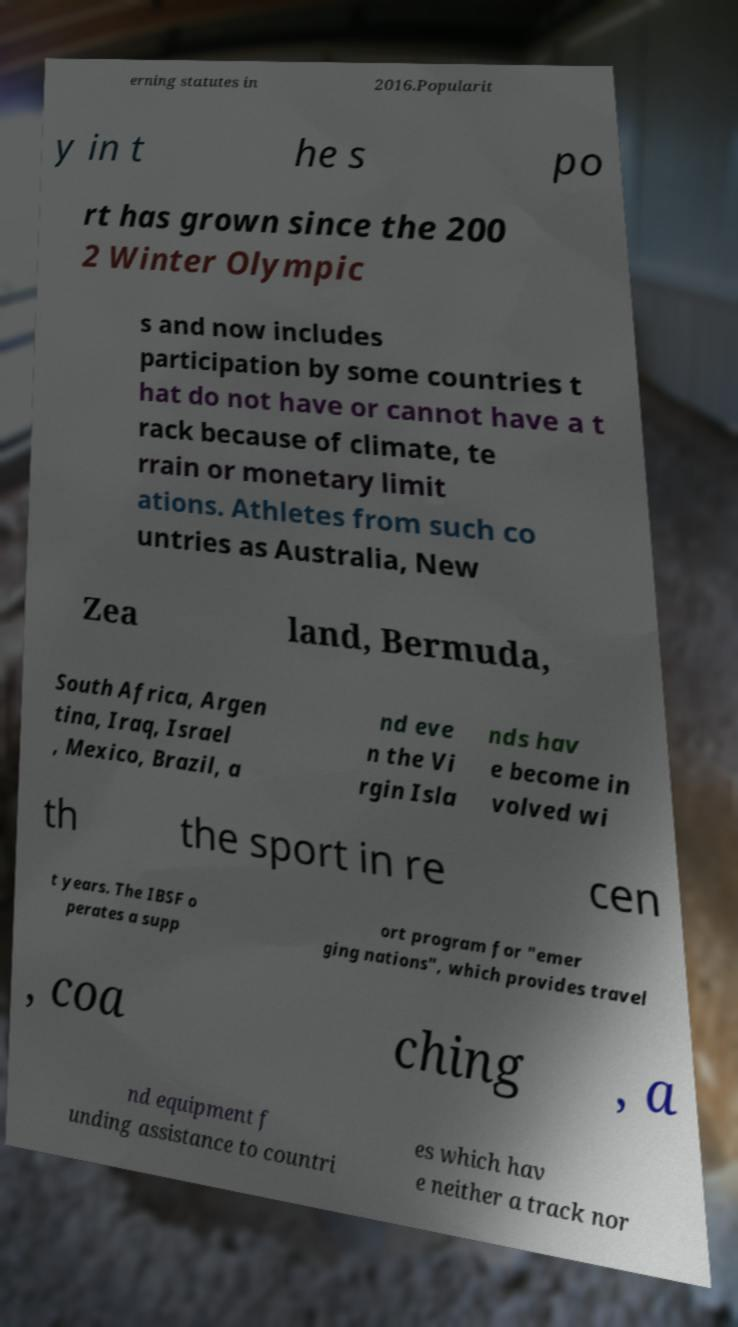What messages or text are displayed in this image? I need them in a readable, typed format. erning statutes in 2016.Popularit y in t he s po rt has grown since the 200 2 Winter Olympic s and now includes participation by some countries t hat do not have or cannot have a t rack because of climate, te rrain or monetary limit ations. Athletes from such co untries as Australia, New Zea land, Bermuda, South Africa, Argen tina, Iraq, Israel , Mexico, Brazil, a nd eve n the Vi rgin Isla nds hav e become in volved wi th the sport in re cen t years. The IBSF o perates a supp ort program for "emer ging nations", which provides travel , coa ching , a nd equipment f unding assistance to countri es which hav e neither a track nor 